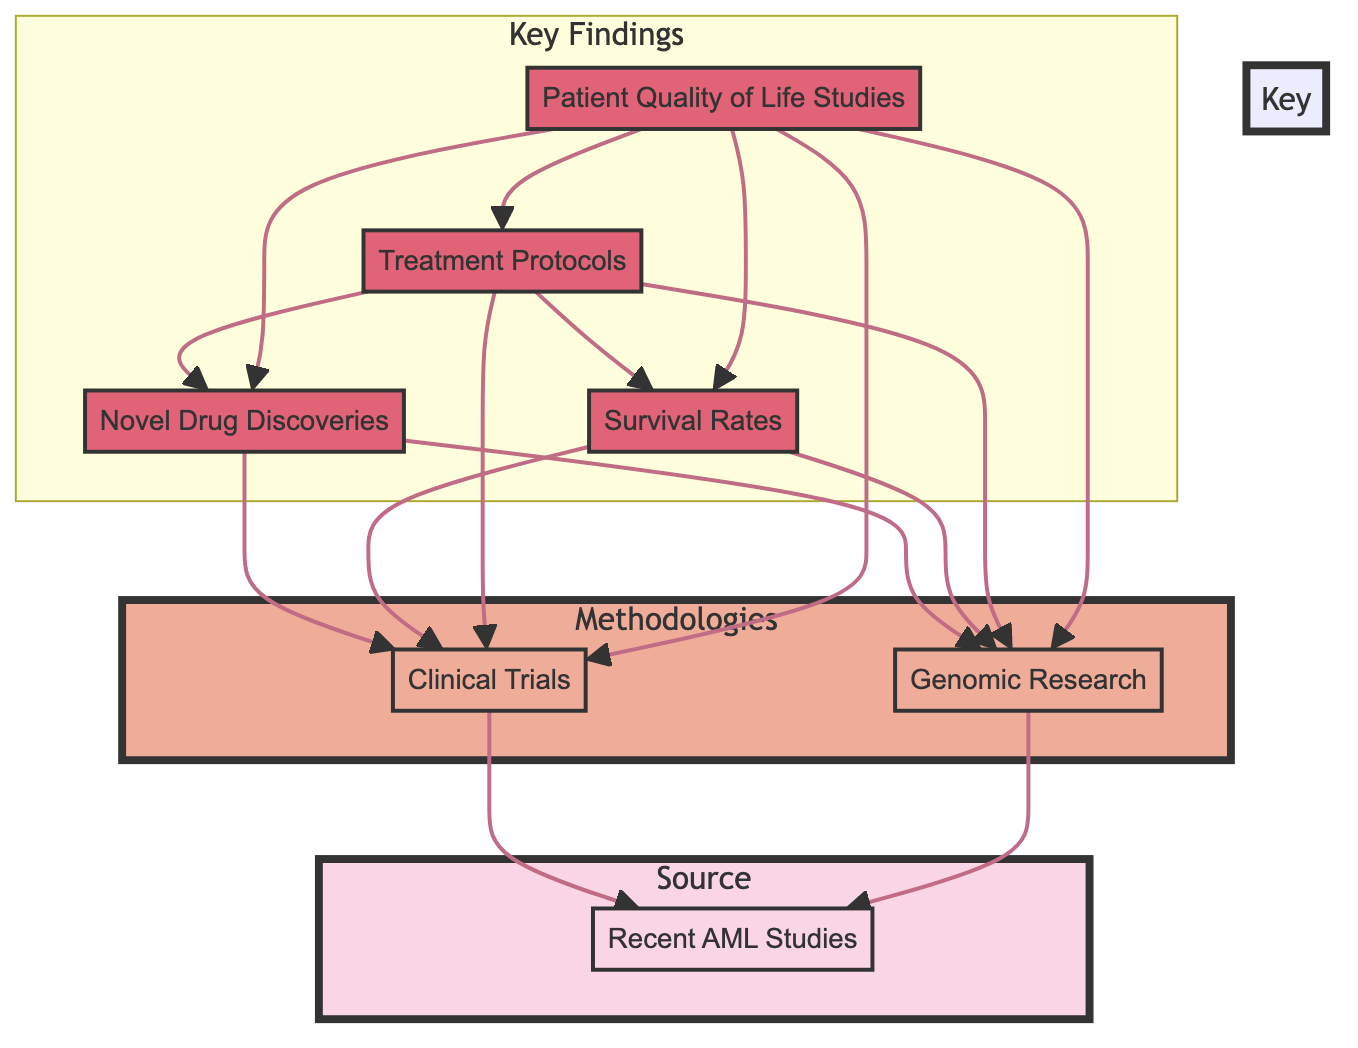What are the categories represented in the diagram? The diagram contains three categories: Source, Methodologies, and Key Findings. Each category is illustrated with nodes that represent specific elements related to Acute Myeloid Leukemia studies.
Answer: Source, Methodologies, Key Findings How many key findings are listed in the diagram? There are four key findings in the diagram: Novel Drug Discoveries, Survival Rates, Treatment Protocols, and Patient Quality of Life Studies. Each of these findings is connected to the methodologies.
Answer: 4 Which methodology connects to both clinical trials and genomic research? The methodologies Clinical Trials and Genomic Research are both connected to the key findings, indicating that they share input from the Recent AML Studies.
Answer: Clinical Trials, Genomic Research What is the relationship between Treatment Protocols and other nodes? Treatment Protocols is influenced by Clinical Trials, Genomic Research, Novel Drug Discoveries, and Survival Rates, suggesting that it integrates findings from all these methodologies and key findings.
Answer: Influenced by multiple nodes Which source informs the methodologies in the diagram? The source informing the methodologies, Clinical Trials and Genomic Research, is the Recent AML Studies. This means that these methodologies are grounded in information from the source.
Answer: Recent AML Studies How do Patient Quality of Life Studies relate to the methodologies? Patient Quality of Life Studies is connected to both Clinical Trials and Genomic Research, implying that the insights from these methodologies are essential to understanding patient quality of life in the context of AML studies.
Answer: Connected to both methodologies Which element has both a methodology and a key finding associated with it? The element that has both a methodology and a key finding associated is Clinical Trials, as it connects to Novel Drug Discoveries, Survival Rates, Treatment Protocols, and Patient Quality of Life Studies.
Answer: Clinical Trials What is the styling color of the source category in the diagram? The source category is styled with a fill color of #f9d5e5, highlighting it distinctly from other categories.
Answer: #f9d5e5 